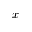<formula> <loc_0><loc_0><loc_500><loc_500>x -</formula> 